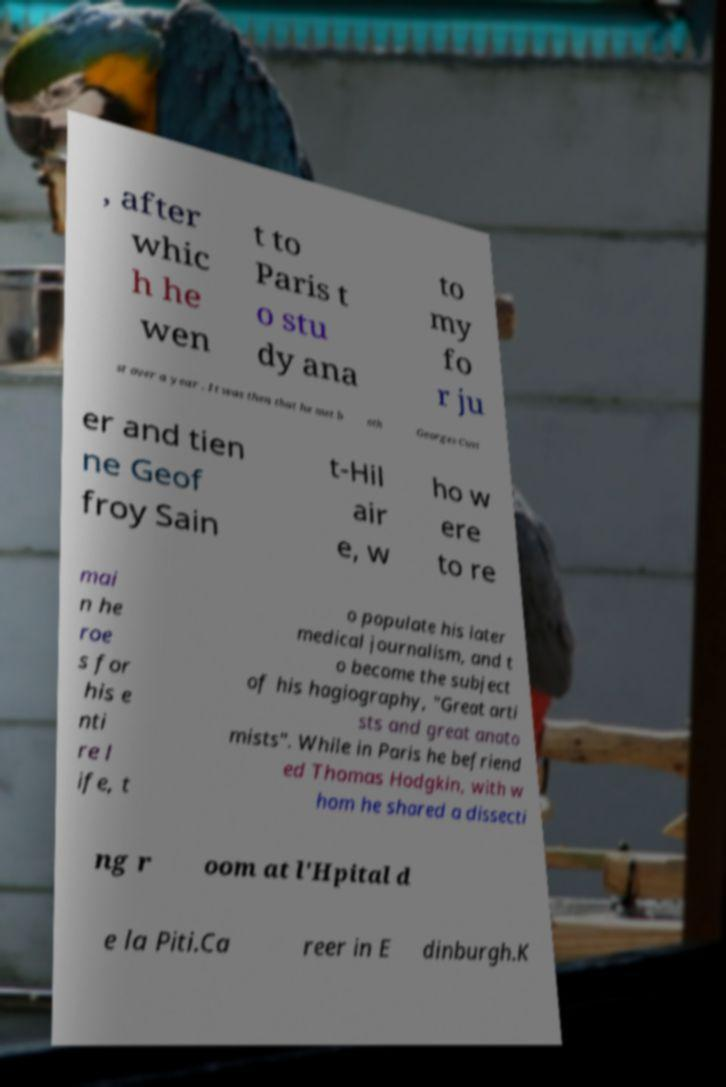For documentation purposes, I need the text within this image transcribed. Could you provide that? , after whic h he wen t to Paris t o stu dy ana to my fo r ju st over a year . It was then that he met b oth Georges Cuvi er and tien ne Geof froy Sain t-Hil air e, w ho w ere to re mai n he roe s for his e nti re l ife, t o populate his later medical journalism, and t o become the subject of his hagiography, "Great arti sts and great anato mists". While in Paris he befriend ed Thomas Hodgkin, with w hom he shared a dissecti ng r oom at l'Hpital d e la Piti.Ca reer in E dinburgh.K 